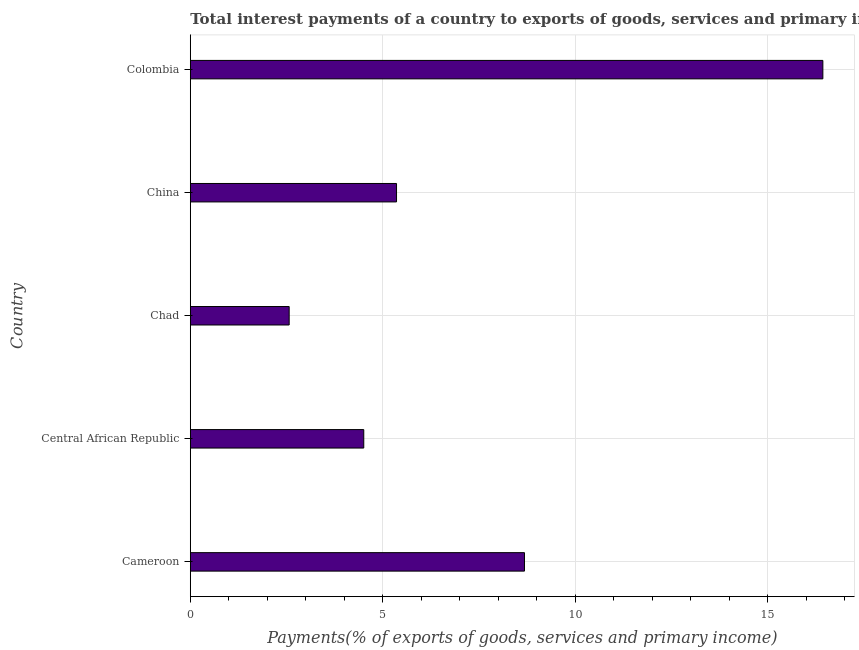Does the graph contain any zero values?
Give a very brief answer. No. What is the title of the graph?
Your answer should be compact. Total interest payments of a country to exports of goods, services and primary income in 1991. What is the label or title of the X-axis?
Keep it short and to the point. Payments(% of exports of goods, services and primary income). What is the total interest payments on external debt in Chad?
Offer a very short reply. 2.57. Across all countries, what is the maximum total interest payments on external debt?
Provide a succinct answer. 16.44. Across all countries, what is the minimum total interest payments on external debt?
Offer a terse response. 2.57. In which country was the total interest payments on external debt maximum?
Offer a very short reply. Colombia. In which country was the total interest payments on external debt minimum?
Offer a very short reply. Chad. What is the sum of the total interest payments on external debt?
Your answer should be compact. 37.56. What is the difference between the total interest payments on external debt in Chad and China?
Provide a short and direct response. -2.79. What is the average total interest payments on external debt per country?
Keep it short and to the point. 7.51. What is the median total interest payments on external debt?
Your response must be concise. 5.36. What is the ratio of the total interest payments on external debt in China to that in Colombia?
Make the answer very short. 0.33. Is the total interest payments on external debt in Cameroon less than that in China?
Your answer should be very brief. No. Is the difference between the total interest payments on external debt in Cameroon and Chad greater than the difference between any two countries?
Keep it short and to the point. No. What is the difference between the highest and the second highest total interest payments on external debt?
Your answer should be compact. 7.75. What is the difference between the highest and the lowest total interest payments on external debt?
Ensure brevity in your answer.  13.87. In how many countries, is the total interest payments on external debt greater than the average total interest payments on external debt taken over all countries?
Make the answer very short. 2. How many bars are there?
Offer a terse response. 5. How many countries are there in the graph?
Give a very brief answer. 5. What is the difference between two consecutive major ticks on the X-axis?
Your response must be concise. 5. What is the Payments(% of exports of goods, services and primary income) of Cameroon?
Ensure brevity in your answer.  8.68. What is the Payments(% of exports of goods, services and primary income) in Central African Republic?
Your answer should be compact. 4.51. What is the Payments(% of exports of goods, services and primary income) in Chad?
Offer a very short reply. 2.57. What is the Payments(% of exports of goods, services and primary income) in China?
Offer a terse response. 5.36. What is the Payments(% of exports of goods, services and primary income) in Colombia?
Offer a very short reply. 16.44. What is the difference between the Payments(% of exports of goods, services and primary income) in Cameroon and Central African Republic?
Make the answer very short. 4.18. What is the difference between the Payments(% of exports of goods, services and primary income) in Cameroon and Chad?
Offer a very short reply. 6.11. What is the difference between the Payments(% of exports of goods, services and primary income) in Cameroon and China?
Ensure brevity in your answer.  3.32. What is the difference between the Payments(% of exports of goods, services and primary income) in Cameroon and Colombia?
Your answer should be compact. -7.75. What is the difference between the Payments(% of exports of goods, services and primary income) in Central African Republic and Chad?
Ensure brevity in your answer.  1.94. What is the difference between the Payments(% of exports of goods, services and primary income) in Central African Republic and China?
Your answer should be very brief. -0.85. What is the difference between the Payments(% of exports of goods, services and primary income) in Central African Republic and Colombia?
Keep it short and to the point. -11.93. What is the difference between the Payments(% of exports of goods, services and primary income) in Chad and China?
Offer a very short reply. -2.79. What is the difference between the Payments(% of exports of goods, services and primary income) in Chad and Colombia?
Offer a very short reply. -13.87. What is the difference between the Payments(% of exports of goods, services and primary income) in China and Colombia?
Offer a terse response. -11.08. What is the ratio of the Payments(% of exports of goods, services and primary income) in Cameroon to that in Central African Republic?
Offer a terse response. 1.93. What is the ratio of the Payments(% of exports of goods, services and primary income) in Cameroon to that in Chad?
Your response must be concise. 3.38. What is the ratio of the Payments(% of exports of goods, services and primary income) in Cameroon to that in China?
Offer a terse response. 1.62. What is the ratio of the Payments(% of exports of goods, services and primary income) in Cameroon to that in Colombia?
Give a very brief answer. 0.53. What is the ratio of the Payments(% of exports of goods, services and primary income) in Central African Republic to that in Chad?
Make the answer very short. 1.75. What is the ratio of the Payments(% of exports of goods, services and primary income) in Central African Republic to that in China?
Provide a short and direct response. 0.84. What is the ratio of the Payments(% of exports of goods, services and primary income) in Central African Republic to that in Colombia?
Your answer should be compact. 0.27. What is the ratio of the Payments(% of exports of goods, services and primary income) in Chad to that in China?
Offer a terse response. 0.48. What is the ratio of the Payments(% of exports of goods, services and primary income) in Chad to that in Colombia?
Ensure brevity in your answer.  0.16. What is the ratio of the Payments(% of exports of goods, services and primary income) in China to that in Colombia?
Give a very brief answer. 0.33. 